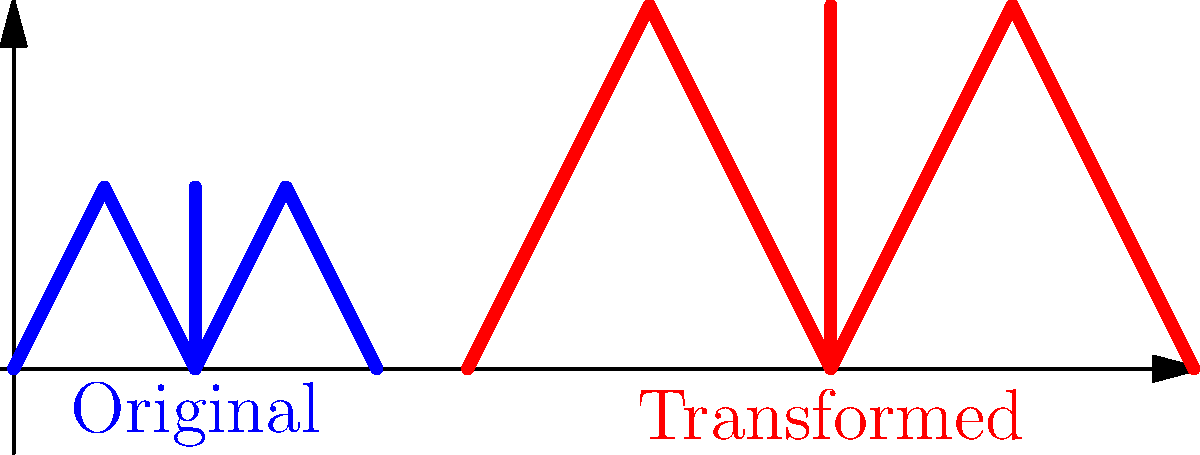A calligraphic letter is represented by the blue shape in the coordinate system. The letter is transformed using a matrix operation to produce the red shape. If the transformation matrix is $$\begin{bmatrix} 2 & 0 \\ 0 & 2 \end{bmatrix}$$, what additional transformation is needed to move the scaled letter to its final position? To solve this problem, let's follow these steps:

1) First, observe that the original blue letter is scaled by a factor of 2 in both x and y directions. This is confirmed by the given transformation matrix:

   $$\begin{bmatrix} 2 & 0 \\ 0 & 2 \end{bmatrix}$$

2) This scaling operation doubles the size of the letter, which we can see in the red shape.

3) However, the red shape is not only larger but also shifted to the right.

4) To determine the shift, we need to compare the positions of a corresponding point in both shapes. Let's use the leftmost point:
   - In the blue shape, it's at (0,0)
   - In the red shape, it's at (5,0)

5) This means that after scaling, the shape was translated 5 units to the right.

6) In matrix notation, a translation is typically represented as an addition:

   $$\begin{bmatrix} x' \\ y' \end{bmatrix} = \begin{bmatrix} x \\ y \end{bmatrix} + \begin{bmatrix} 5 \\ 0 \end{bmatrix}$$

Therefore, the additional transformation needed is a translation of 5 units in the positive x-direction.
Answer: Translation by (5,0) 